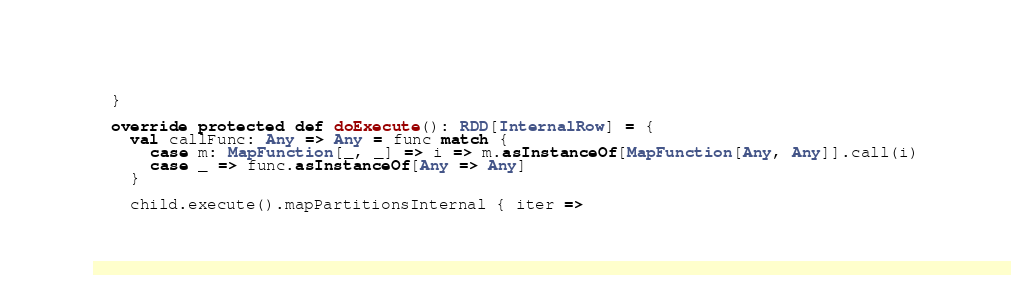Convert code to text. <code><loc_0><loc_0><loc_500><loc_500><_Scala_>  }

  override protected def doExecute(): RDD[InternalRow] = {
    val callFunc: Any => Any = func match {
      case m: MapFunction[_, _] => i => m.asInstanceOf[MapFunction[Any, Any]].call(i)
      case _ => func.asInstanceOf[Any => Any]
    }

    child.execute().mapPartitionsInternal { iter =></code> 